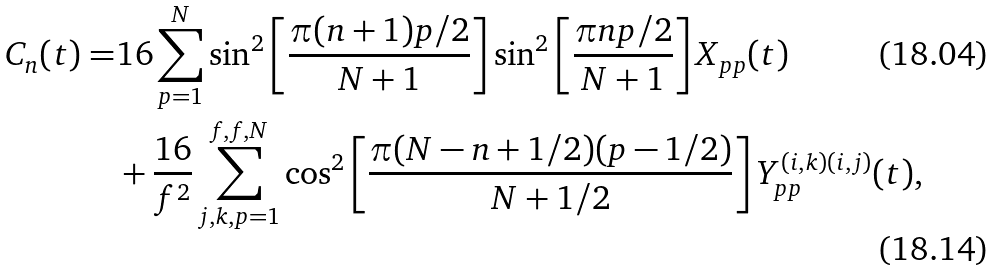<formula> <loc_0><loc_0><loc_500><loc_500>C _ { n } ( t ) = & 1 6 \sum _ { p = 1 } ^ { N } \sin ^ { 2 } \left [ \frac { \pi ( n + 1 ) p / 2 } { N + 1 } \right ] \sin ^ { 2 } \left [ \frac { \pi n p / 2 } { N + 1 } \right ] X _ { p p } ( t ) \\ & + \frac { 1 6 } { f ^ { 2 } } \sum _ { j , k , p = 1 } ^ { f , f , N } \cos ^ { 2 } \left [ \frac { \pi ( N - n + 1 / 2 ) ( p - 1 / 2 ) } { N + 1 / 2 } \right ] Y _ { p p } ^ { ( i , k ) ( i , j ) } ( t ) ,</formula> 